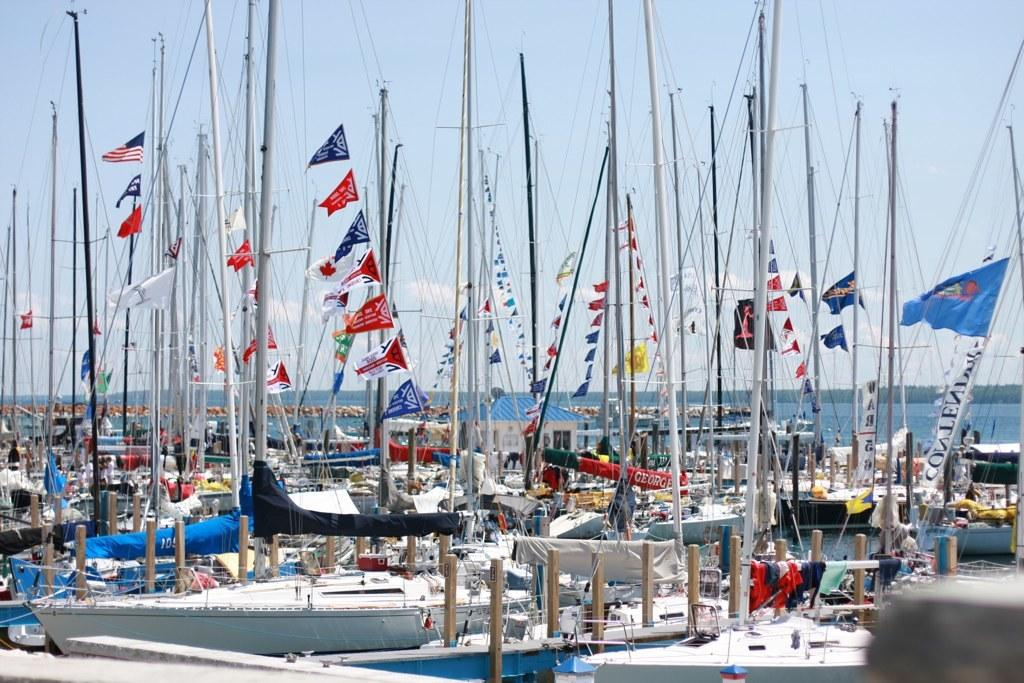What type of vehicles can be seen in the image? There are ships in the image. What are the ships displaying in the image? There are flags in the image. What are the flags attached to in the image? There are poles in the image. What else can be seen in the image besides the ships, flags, and poles? There are other objects in the image. What is visible in the background of the image? Water and the sky are visible in the background of the image. How many eggs are being used to create the division between the ships in the image? There are no eggs or divisions between the ships in the image; it features ships, flags, poles, and other objects. What type of trouble are the ships facing in the image? There is no indication of trouble or any specific issue facing the ships in the image. 